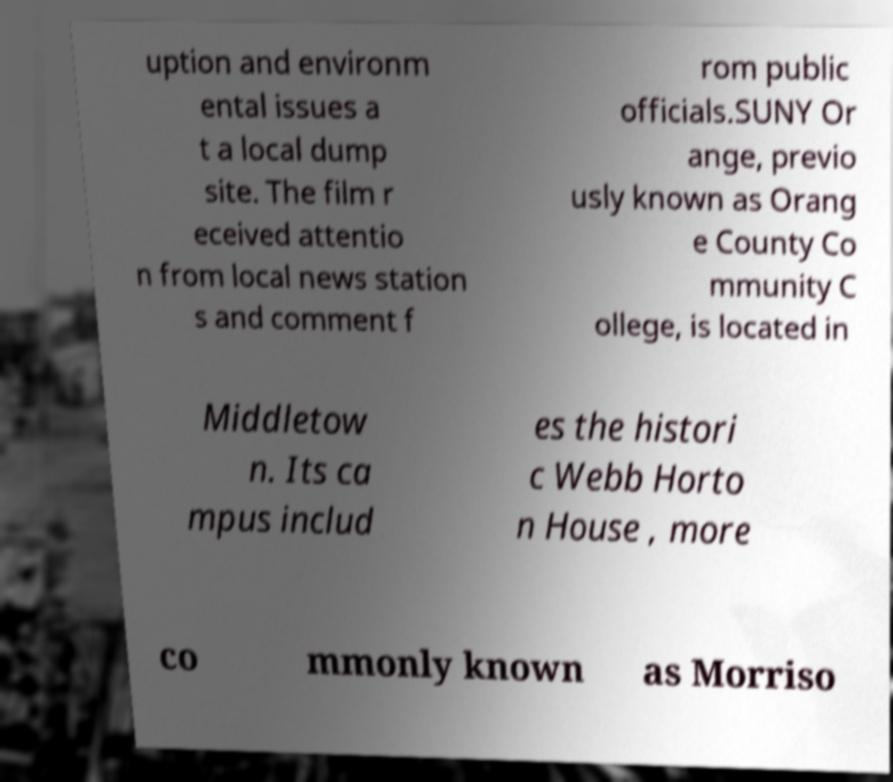Can you accurately transcribe the text from the provided image for me? uption and environm ental issues a t a local dump site. The film r eceived attentio n from local news station s and comment f rom public officials.SUNY Or ange, previo usly known as Orang e County Co mmunity C ollege, is located in Middletow n. Its ca mpus includ es the histori c Webb Horto n House , more co mmonly known as Morriso 